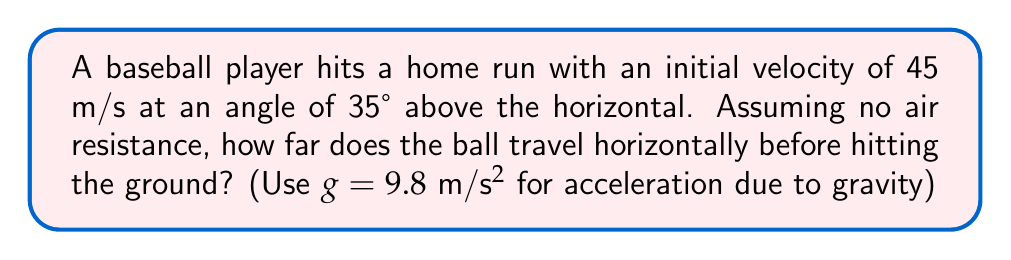Could you help me with this problem? To solve this problem, we'll use the quadratic equation for projectile motion:

1) The quadratic equation for projectile motion is:
   $$y = -\frac{1}{2}gt^2 + v_0\sin(\theta)t + y_0$$

   Where:
   $y$ is the vertical position
   $g$ is the acceleration due to gravity (9.8 m/s²)
   $t$ is time
   $v_0$ is initial velocity
   $\theta$ is the launch angle
   $y_0$ is the initial height (0 in this case)

2) We want to find when $y = 0$ (ball hits the ground). So:
   $$0 = -\frac{1}{2}(9.8)t^2 + 45\sin(35°)t + 0$$

3) Simplify:
   $$0 = -4.9t^2 + 25.8t$$

4) Factor out $t$:
   $$t(25.8 - 4.9t) = 0$$

5) Solve for $t$:
   $t = 0$ or $t = 5.27$ seconds

6) We use $t = 5.27s$ as it represents when the ball hits the ground.

7) To find the horizontal distance, we use:
   $$x = v_0\cos(\theta)t$$

8) Calculate:
   $$x = 45\cos(35°)(5.27) = 193.2 \text{ meters}$$

Therefore, the ball travels approximately 193.2 meters horizontally.
Answer: 193.2 meters 